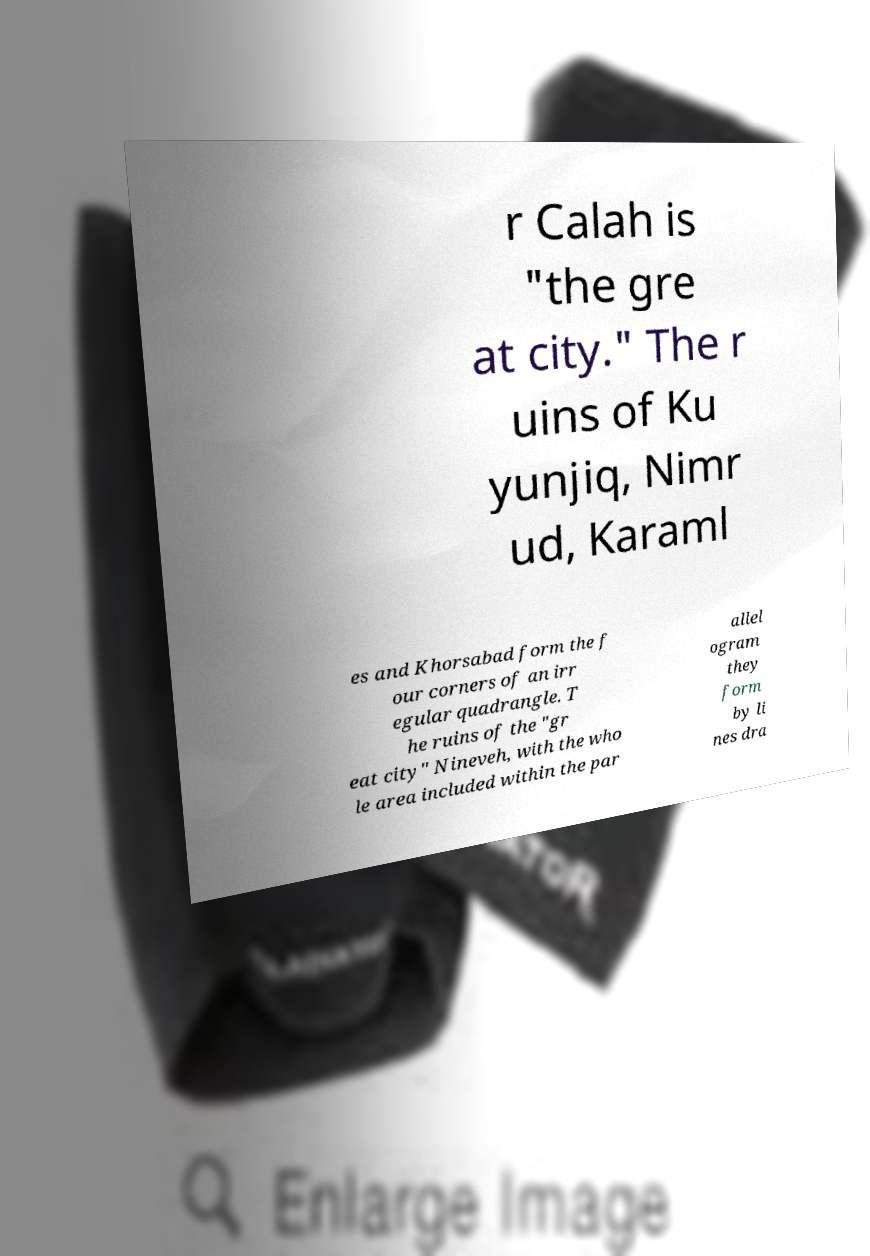Could you assist in decoding the text presented in this image and type it out clearly? r Calah is "the gre at city." The r uins of Ku yunjiq, Nimr ud, Karaml es and Khorsabad form the f our corners of an irr egular quadrangle. T he ruins of the "gr eat city" Nineveh, with the who le area included within the par allel ogram they form by li nes dra 